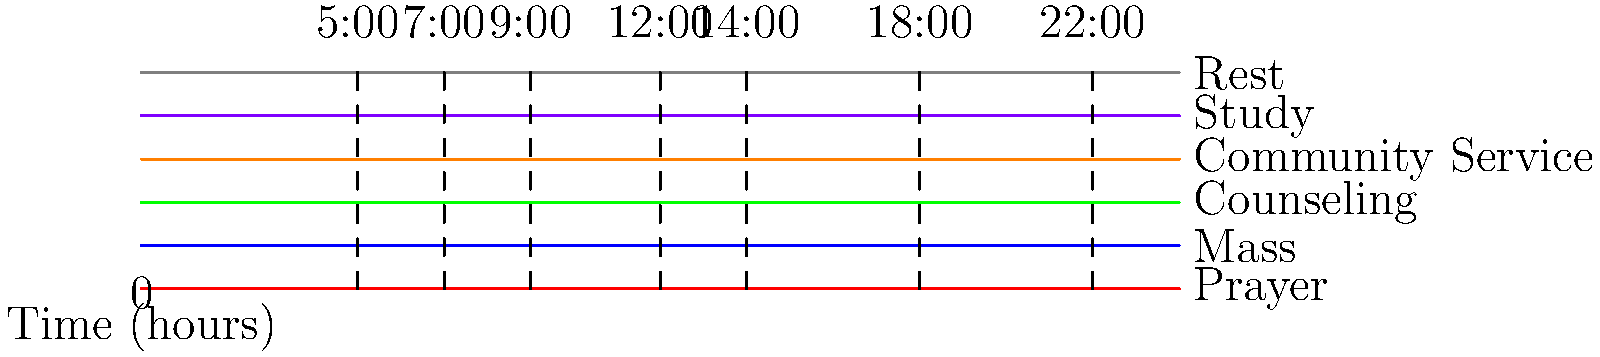Based on the daily schedule timeline for a priest, what activity immediately follows the morning Mass? To answer this question, let's analyze the timeline step-by-step:

1. The timeline shows six main activities: Prayer, Mass, Counseling, Community Service, Study, and Rest.

2. Each activity is represented by a colored horizontal line spanning different time periods throughout the day.

3. The morning Mass is typically represented by the blue line, which appears to start at 7:00 AM and end at 9:00 AM.

4. After the 9:00 AM mark, we need to identify which activity line begins immediately after the Mass ends.

5. Looking at the timeline, we can see that the green line, representing Counseling, starts right after the Mass ends at 9:00 AM.

6. The Counseling activity continues until 12:00 PM (noon).

Therefore, based on this daily schedule timeline, the activity that immediately follows the morning Mass is Counseling.
Answer: Counseling 